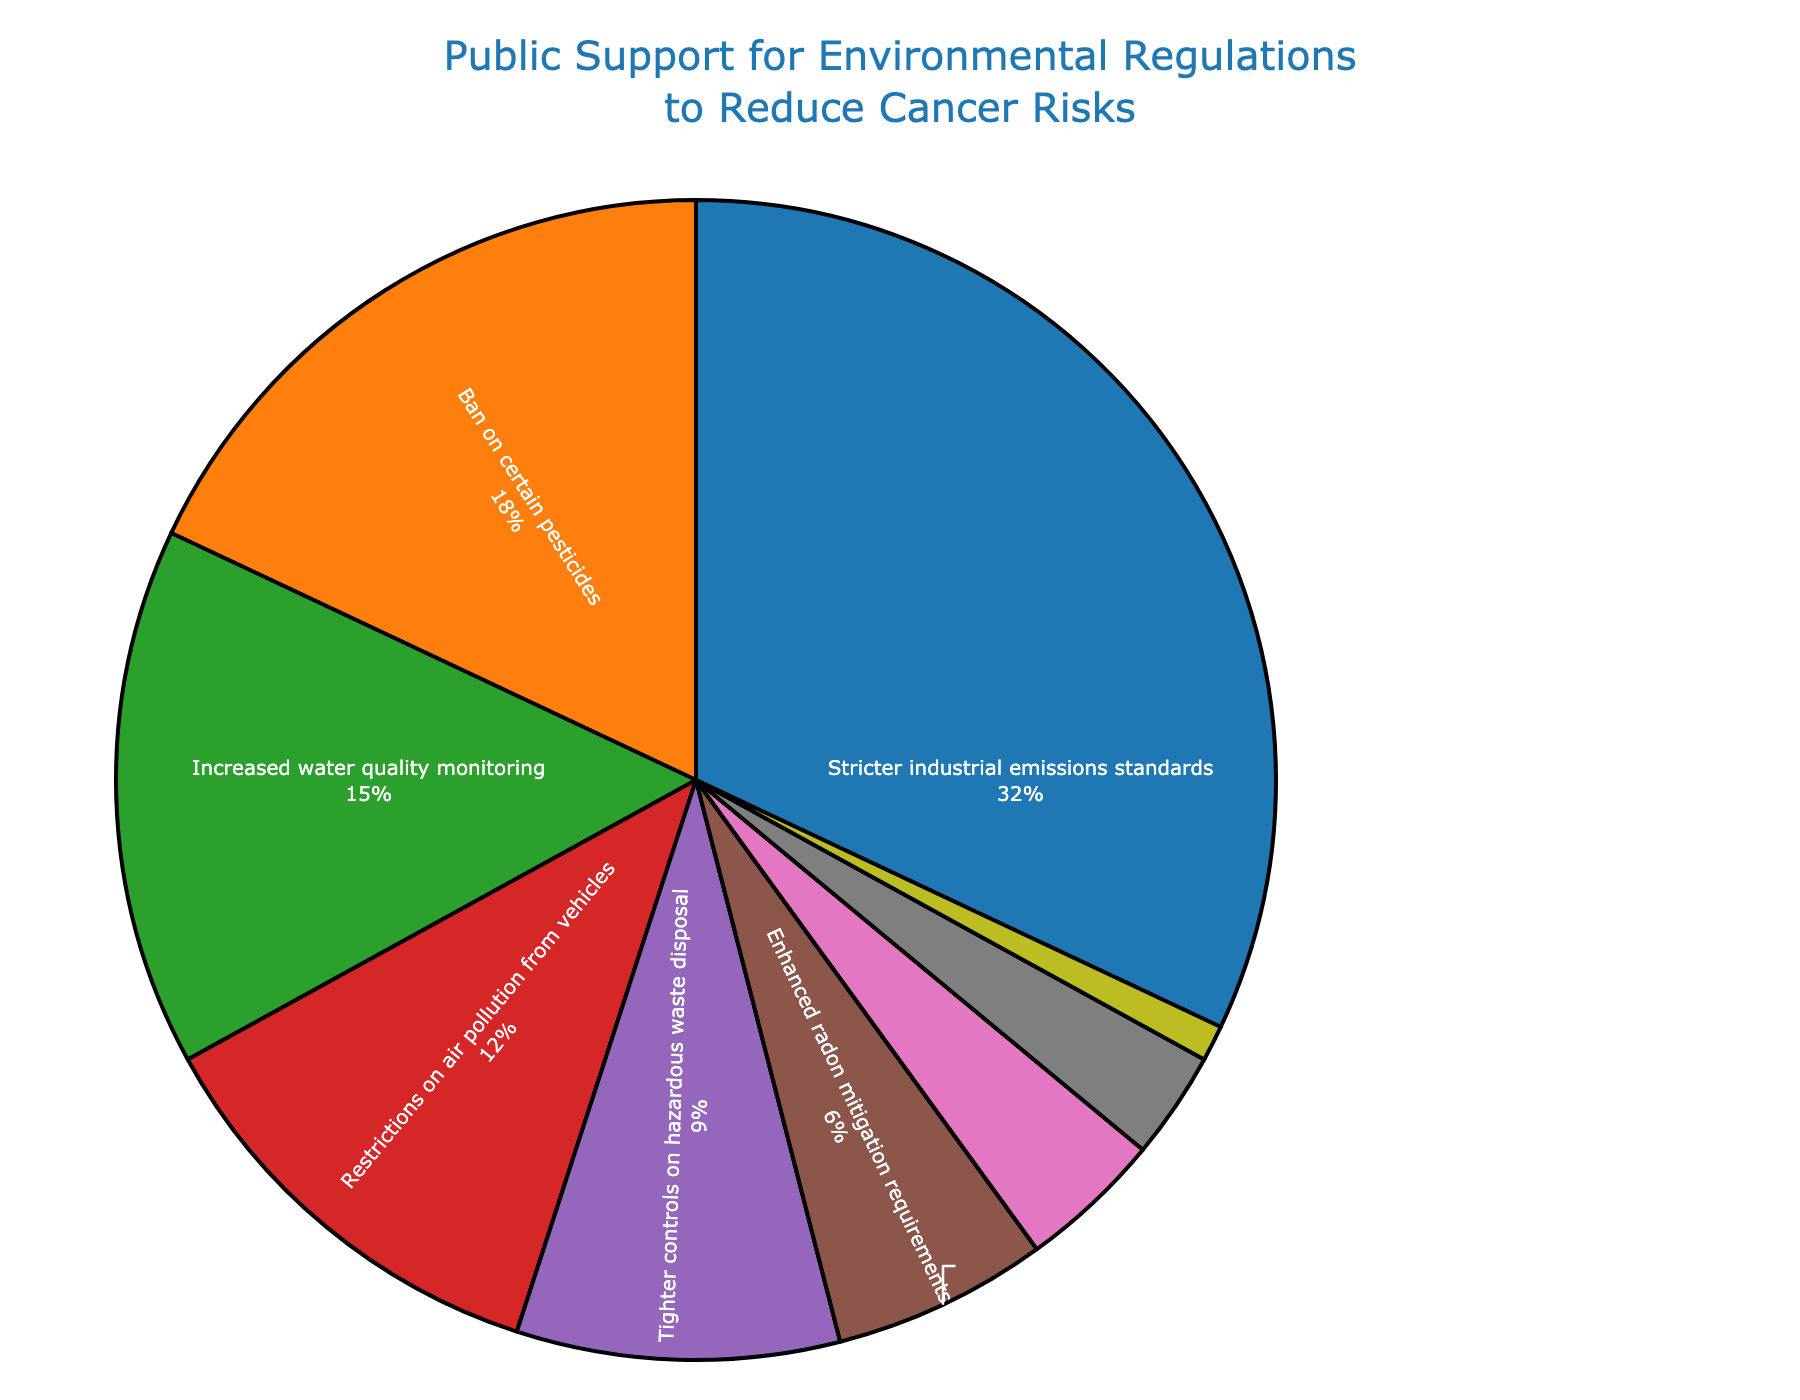What percentage of support is dedicated to stricter industrial emissions standards? The slice labeled "Stricter industrial emissions standards" shows the support percentage. It is labeled with both the type of regulation and the percentage of support.
Answer: 32% How much more support do stricter industrial emissions standards have compared to restrictions on air pollution from vehicles? Subtract the percentage support for "Restrictions on air pollution from vehicles" (12%) from the percentage support for "Stricter industrial emissions standards" (32%).
Answer: 20% What is the combined support percentage for increased water quality monitoring and tighter controls on hazardous waste disposal? Add the support percentages for "Increased water quality monitoring" (15%) and "Tighter controls on hazardous waste disposal" (9%).
Answer: 24% Which regulation type has the least public support? The pie chart shows the regulation types and their support percentages. The smallest slice represents "Limitations on electromagnetic field exposure" with 1%.
Answer: Limitations on electromagnetic field exposure What color represents the regulation type with the second-highest support percentage? The pie chart uses colors to differentiate regulation types. The regulation with the second-highest support is "Ban on certain pesticides" at 18%, shown in orange.
Answer: Orange How does the combined support for stronger regulations on food additives and enhanced radon mitigation requirements compare to the support for a ban on certain pesticides? Add the support percentages for "Stronger regulations on food additives" (4%) and "Enhanced radon mitigation requirements" (6%). Compare their sum (10%) to the support percentage for "Ban on certain pesticides" (18%).
Answer: 8% less Which regulation types have a support percentage of less than 10%? Look for slices with less than a 10% label. These include "Tighter controls on hazardous waste disposal" (9%), "Enhanced radon mitigation requirements" (6%), "Stronger regulations on food additives" (4%), "Improved occupational safety standards" (3%), and "Limitations on electromagnetic field exposure" (1%).
Answer: 5 types What percentage of support is dedicated to regulations on environmental factors directly impacting indoor spaces (i.e., enhanced radon mitigation requirements and stronger regulations on food additives)? Add the support percentages for "Enhanced radon mitigation requirements" (6%) and "Stronger regulations on food additives" (4%).
Answer: 10% How much higher is the support for stricter industrial emissions standards than the support for improved occupational safety standards? Subtract the percentage of support for "Improved occupational safety standards" (3%) from the percentage of support for "Stricter industrial emissions standards" (32%).
Answer: 29% What is the average support percentage across all shown regulation types? Add all support percentages: 32 + 18 + 15 + 12 + 9 + 6 + 4 + 3 + 1 = 100. Divide the total by the number of regulation types (9).
Answer: 11.11% 